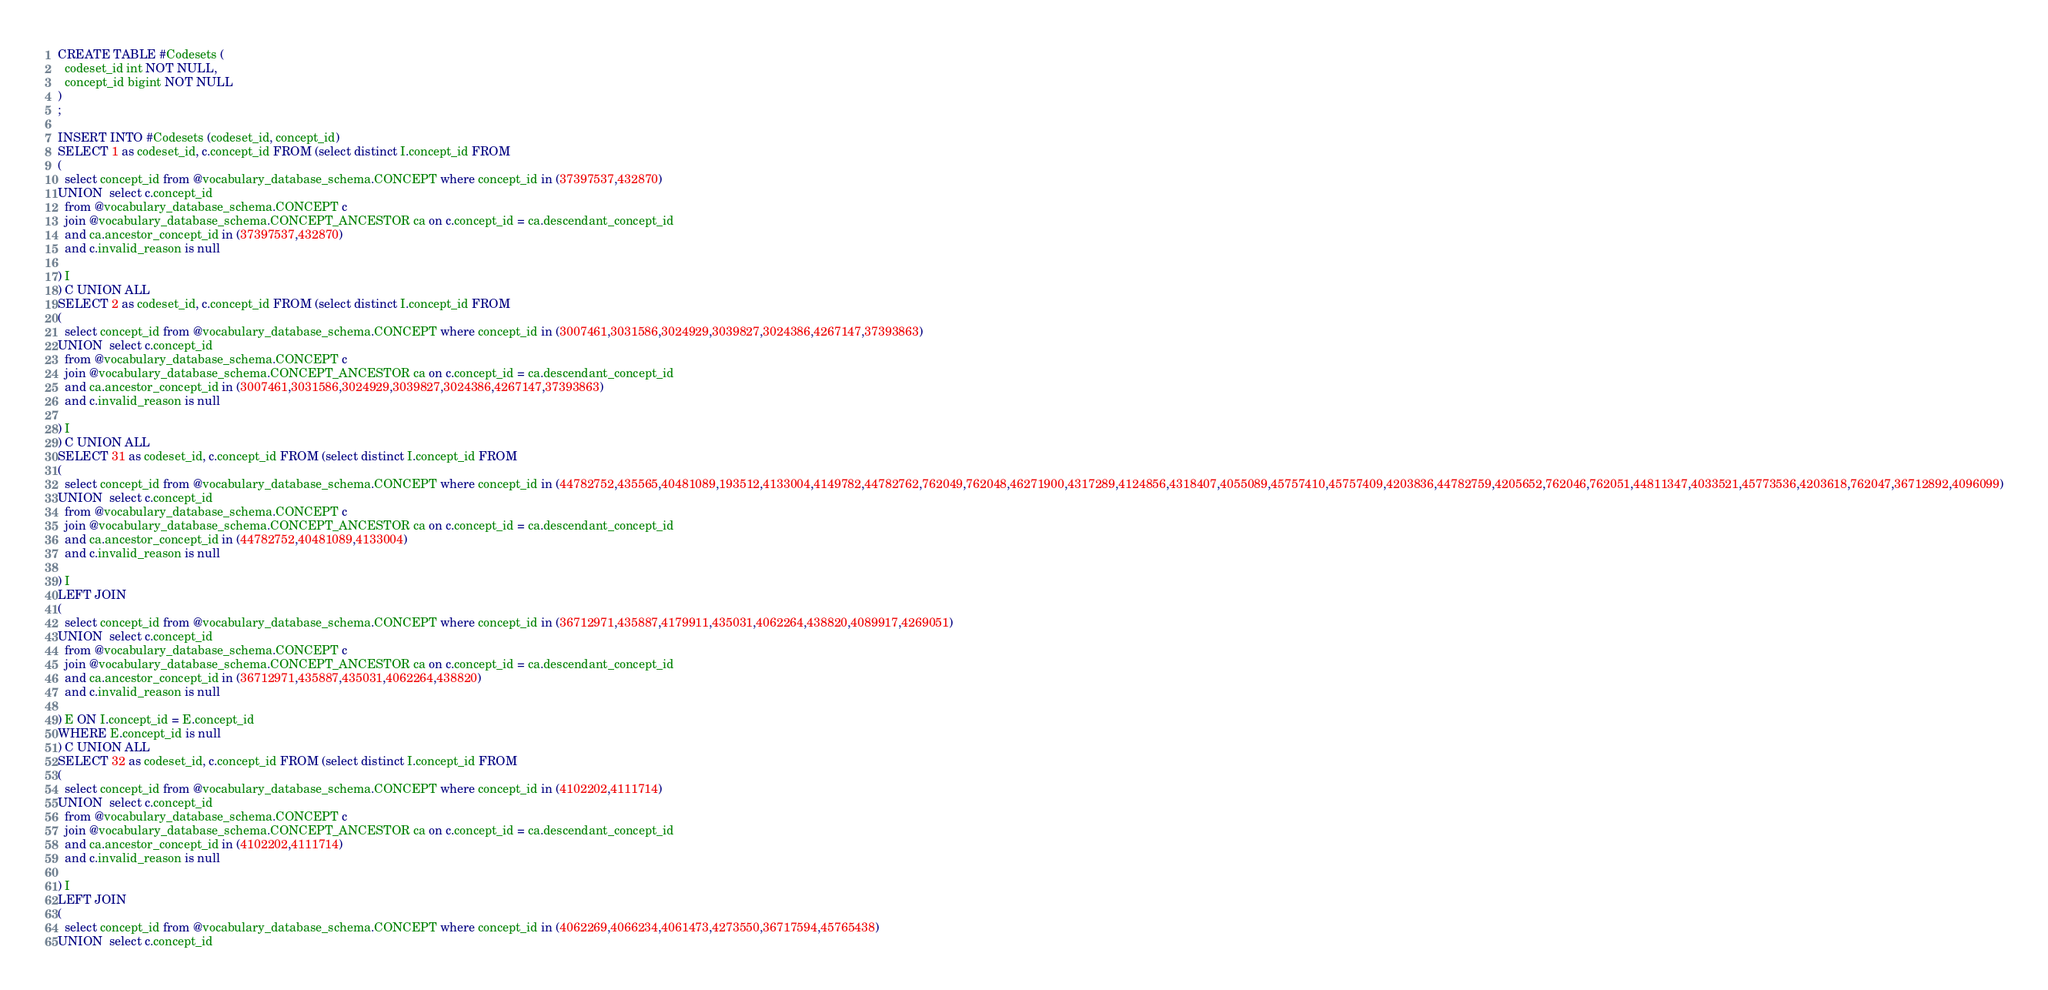Convert code to text. <code><loc_0><loc_0><loc_500><loc_500><_SQL_>CREATE TABLE #Codesets (
  codeset_id int NOT NULL,
  concept_id bigint NOT NULL
)
;

INSERT INTO #Codesets (codeset_id, concept_id)
SELECT 1 as codeset_id, c.concept_id FROM (select distinct I.concept_id FROM
( 
  select concept_id from @vocabulary_database_schema.CONCEPT where concept_id in (37397537,432870)
UNION  select c.concept_id
  from @vocabulary_database_schema.CONCEPT c
  join @vocabulary_database_schema.CONCEPT_ANCESTOR ca on c.concept_id = ca.descendant_concept_id
  and ca.ancestor_concept_id in (37397537,432870)
  and c.invalid_reason is null

) I
) C UNION ALL 
SELECT 2 as codeset_id, c.concept_id FROM (select distinct I.concept_id FROM
( 
  select concept_id from @vocabulary_database_schema.CONCEPT where concept_id in (3007461,3031586,3024929,3039827,3024386,4267147,37393863)
UNION  select c.concept_id
  from @vocabulary_database_schema.CONCEPT c
  join @vocabulary_database_schema.CONCEPT_ANCESTOR ca on c.concept_id = ca.descendant_concept_id
  and ca.ancestor_concept_id in (3007461,3031586,3024929,3039827,3024386,4267147,37393863)
  and c.invalid_reason is null

) I
) C UNION ALL 
SELECT 31 as codeset_id, c.concept_id FROM (select distinct I.concept_id FROM
( 
  select concept_id from @vocabulary_database_schema.CONCEPT where concept_id in (44782752,435565,40481089,193512,4133004,4149782,44782762,762049,762048,46271900,4317289,4124856,4318407,4055089,45757410,45757409,4203836,44782759,4205652,762046,762051,44811347,4033521,45773536,4203618,762047,36712892,4096099)
UNION  select c.concept_id
  from @vocabulary_database_schema.CONCEPT c
  join @vocabulary_database_schema.CONCEPT_ANCESTOR ca on c.concept_id = ca.descendant_concept_id
  and ca.ancestor_concept_id in (44782752,40481089,4133004)
  and c.invalid_reason is null

) I
LEFT JOIN
(
  select concept_id from @vocabulary_database_schema.CONCEPT where concept_id in (36712971,435887,4179911,435031,4062264,438820,4089917,4269051)
UNION  select c.concept_id
  from @vocabulary_database_schema.CONCEPT c
  join @vocabulary_database_schema.CONCEPT_ANCESTOR ca on c.concept_id = ca.descendant_concept_id
  and ca.ancestor_concept_id in (36712971,435887,435031,4062264,438820)
  and c.invalid_reason is null

) E ON I.concept_id = E.concept_id
WHERE E.concept_id is null
) C UNION ALL 
SELECT 32 as codeset_id, c.concept_id FROM (select distinct I.concept_id FROM
( 
  select concept_id from @vocabulary_database_schema.CONCEPT where concept_id in (4102202,4111714)
UNION  select c.concept_id
  from @vocabulary_database_schema.CONCEPT c
  join @vocabulary_database_schema.CONCEPT_ANCESTOR ca on c.concept_id = ca.descendant_concept_id
  and ca.ancestor_concept_id in (4102202,4111714)
  and c.invalid_reason is null

) I
LEFT JOIN
(
  select concept_id from @vocabulary_database_schema.CONCEPT where concept_id in (4062269,4066234,4061473,4273550,36717594,45765438)
UNION  select c.concept_id</code> 